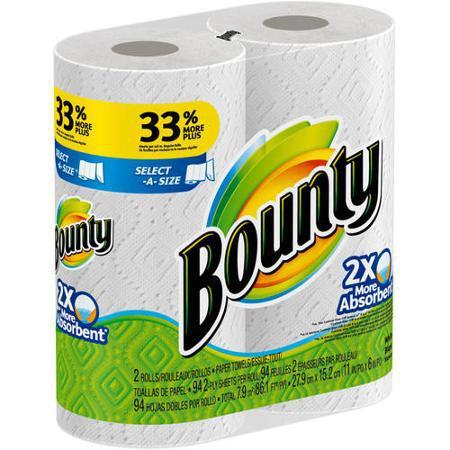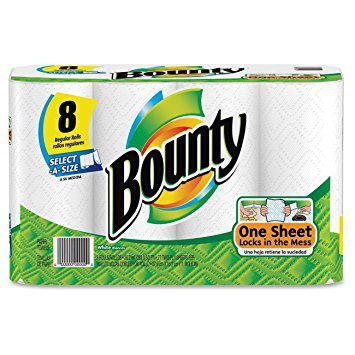The first image is the image on the left, the second image is the image on the right. Analyze the images presented: Is the assertion "The color scheme on the paper towel products on the left and right is primarily green, and each image contains exactly one multipack of paper towels." valid? Answer yes or no. Yes. The first image is the image on the left, the second image is the image on the right. Examine the images to the left and right. Is the description "There are more than thirteen rolls." accurate? Answer yes or no. No. 